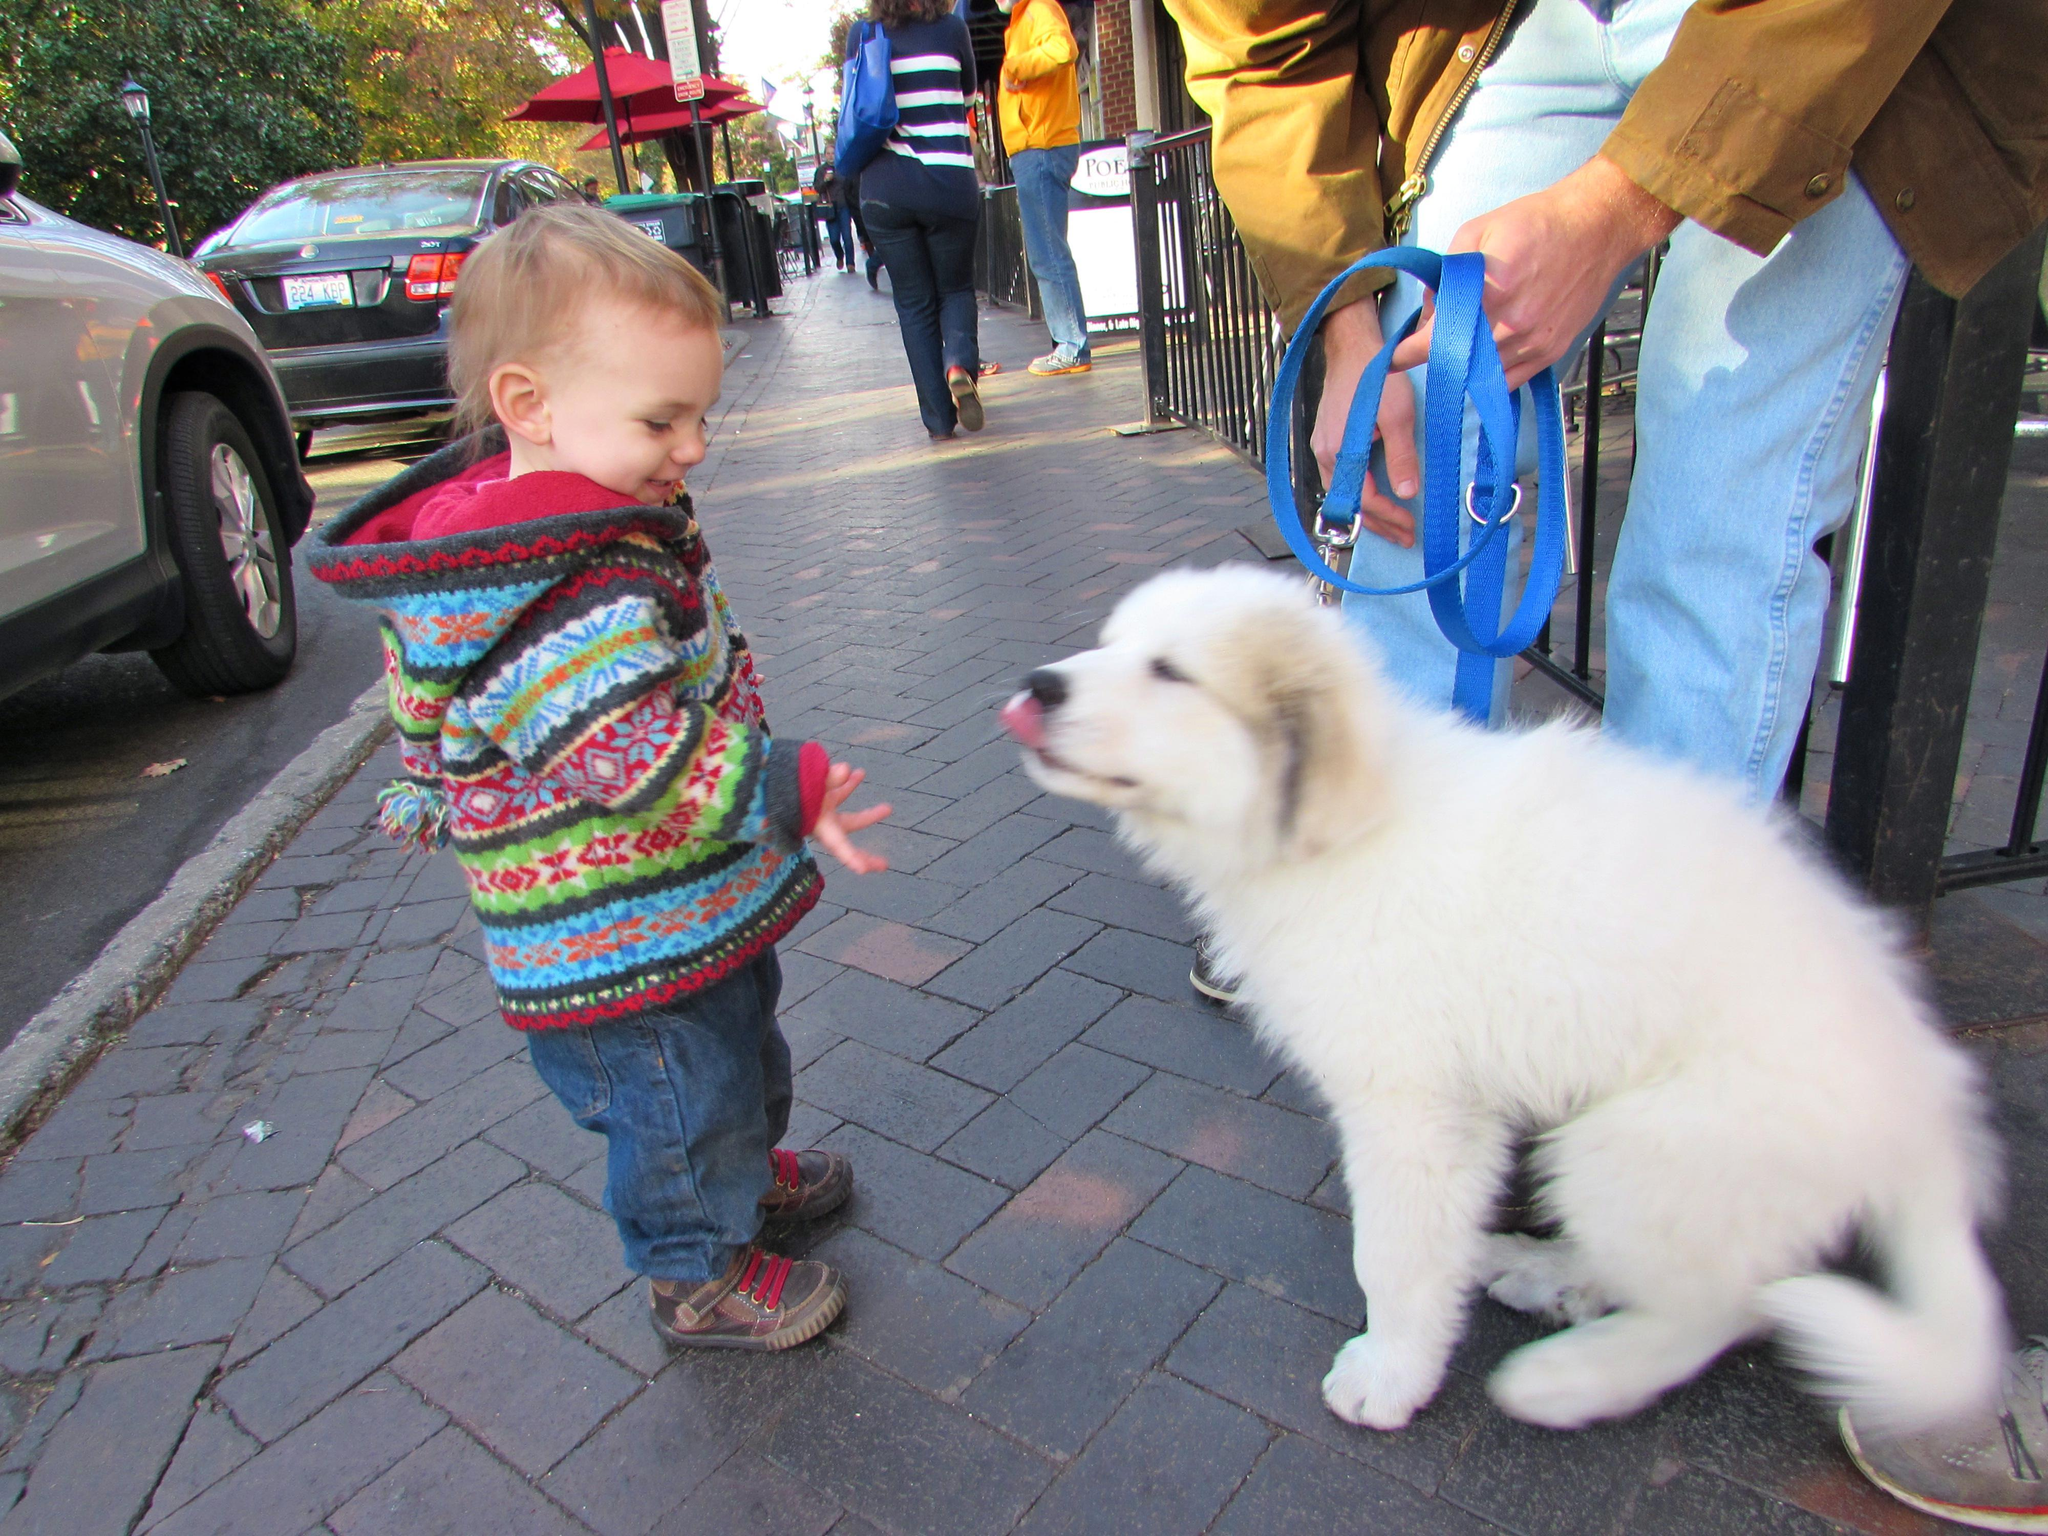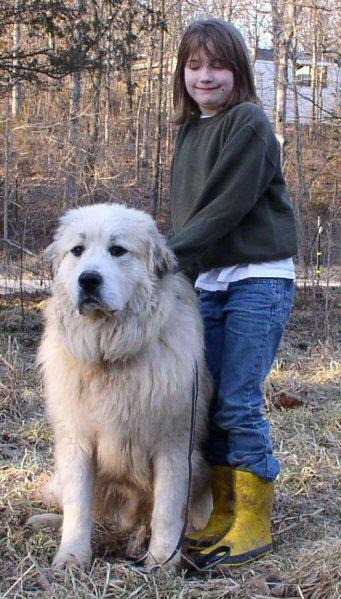The first image is the image on the left, the second image is the image on the right. Assess this claim about the two images: "In one of the images there is a person holding a large white dog.". Correct or not? Answer yes or no. No. The first image is the image on the left, the second image is the image on the right. Assess this claim about the two images: "An image shows a toddler next to a sitting white dog.". Correct or not? Answer yes or no. Yes. 